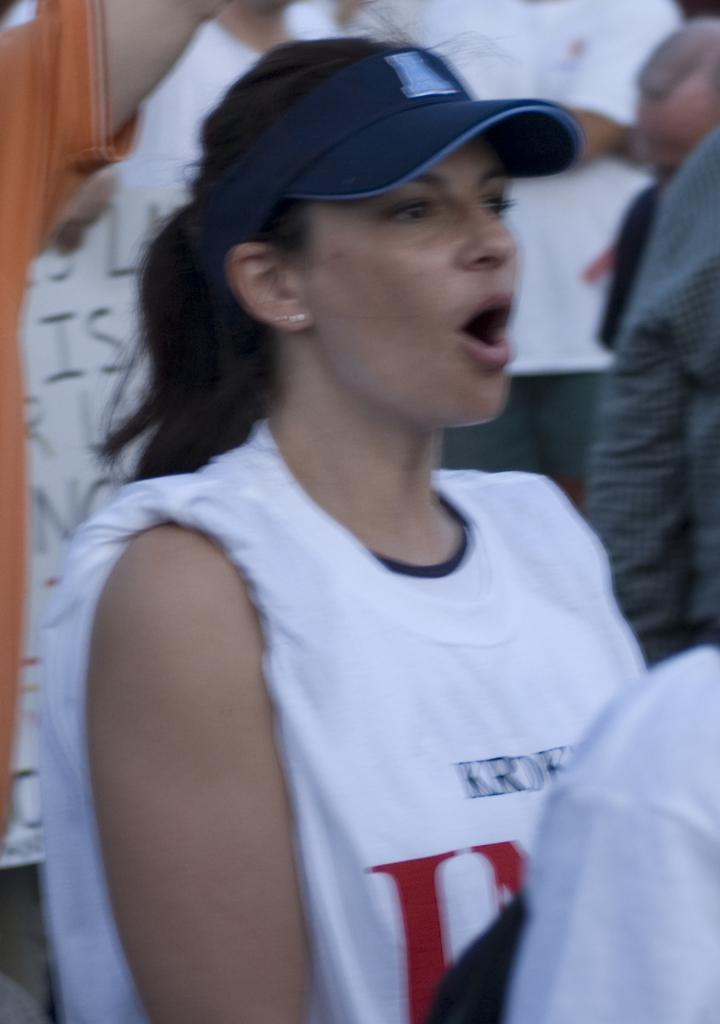Who is the main subject in the image? There is a woman in the image. Where is the woman positioned in the image? The woman is standing at the center. What is the woman wearing on her head? The woman is wearing a blue hat. What can be seen in the background of the image? There are persons and a board with text in the background of the image. What type of creature is sitting next to the woman in the image? There is no creature present in the image; it only features the woman and the background elements. 